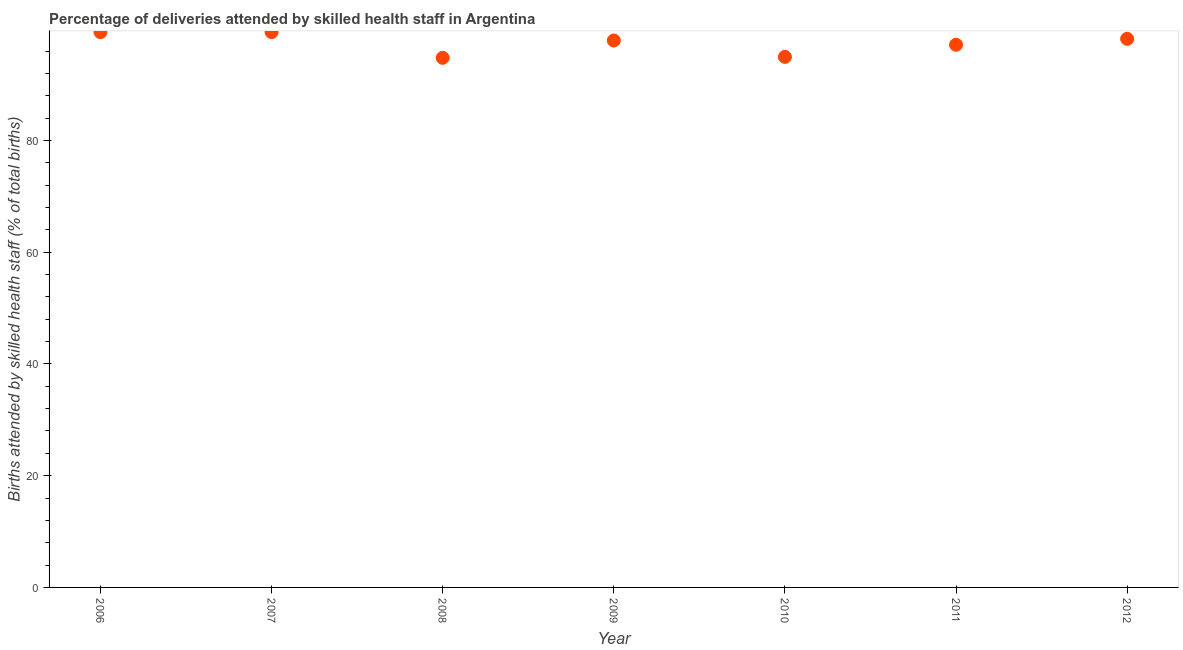What is the number of births attended by skilled health staff in 2007?
Make the answer very short. 99.4. Across all years, what is the maximum number of births attended by skilled health staff?
Your response must be concise. 99.4. Across all years, what is the minimum number of births attended by skilled health staff?
Provide a short and direct response. 94.8. In which year was the number of births attended by skilled health staff minimum?
Ensure brevity in your answer.  2008. What is the sum of the number of births attended by skilled health staff?
Provide a succinct answer. 681.81. What is the difference between the number of births attended by skilled health staff in 2007 and 2010?
Your answer should be compact. 4.43. What is the average number of births attended by skilled health staff per year?
Offer a very short reply. 97.4. What is the median number of births attended by skilled health staff?
Offer a very short reply. 97.9. In how many years, is the number of births attended by skilled health staff greater than 88 %?
Provide a short and direct response. 7. What is the ratio of the number of births attended by skilled health staff in 2008 to that in 2011?
Offer a terse response. 0.98. Is the sum of the number of births attended by skilled health staff in 2011 and 2012 greater than the maximum number of births attended by skilled health staff across all years?
Ensure brevity in your answer.  Yes. What is the difference between the highest and the lowest number of births attended by skilled health staff?
Give a very brief answer. 4.6. What is the difference between two consecutive major ticks on the Y-axis?
Provide a succinct answer. 20. Does the graph contain any zero values?
Your answer should be very brief. No. Does the graph contain grids?
Give a very brief answer. No. What is the title of the graph?
Your answer should be compact. Percentage of deliveries attended by skilled health staff in Argentina. What is the label or title of the X-axis?
Provide a short and direct response. Year. What is the label or title of the Y-axis?
Keep it short and to the point. Births attended by skilled health staff (% of total births). What is the Births attended by skilled health staff (% of total births) in 2006?
Provide a short and direct response. 99.4. What is the Births attended by skilled health staff (% of total births) in 2007?
Provide a succinct answer. 99.4. What is the Births attended by skilled health staff (% of total births) in 2008?
Your response must be concise. 94.8. What is the Births attended by skilled health staff (% of total births) in 2009?
Keep it short and to the point. 97.9. What is the Births attended by skilled health staff (% of total births) in 2010?
Provide a succinct answer. 94.97. What is the Births attended by skilled health staff (% of total births) in 2011?
Ensure brevity in your answer.  97.14. What is the Births attended by skilled health staff (% of total births) in 2012?
Offer a very short reply. 98.2. What is the difference between the Births attended by skilled health staff (% of total births) in 2006 and 2009?
Give a very brief answer. 1.5. What is the difference between the Births attended by skilled health staff (% of total births) in 2006 and 2010?
Ensure brevity in your answer.  4.43. What is the difference between the Births attended by skilled health staff (% of total births) in 2006 and 2011?
Your answer should be very brief. 2.26. What is the difference between the Births attended by skilled health staff (% of total births) in 2006 and 2012?
Ensure brevity in your answer.  1.2. What is the difference between the Births attended by skilled health staff (% of total births) in 2007 and 2009?
Your answer should be compact. 1.5. What is the difference between the Births attended by skilled health staff (% of total births) in 2007 and 2010?
Ensure brevity in your answer.  4.43. What is the difference between the Births attended by skilled health staff (% of total births) in 2007 and 2011?
Provide a short and direct response. 2.26. What is the difference between the Births attended by skilled health staff (% of total births) in 2007 and 2012?
Your response must be concise. 1.2. What is the difference between the Births attended by skilled health staff (% of total births) in 2008 and 2010?
Your response must be concise. -0.17. What is the difference between the Births attended by skilled health staff (% of total births) in 2008 and 2011?
Give a very brief answer. -2.34. What is the difference between the Births attended by skilled health staff (% of total births) in 2009 and 2010?
Provide a short and direct response. 2.93. What is the difference between the Births attended by skilled health staff (% of total births) in 2009 and 2011?
Offer a very short reply. 0.76. What is the difference between the Births attended by skilled health staff (% of total births) in 2010 and 2011?
Give a very brief answer. -2.17. What is the difference between the Births attended by skilled health staff (% of total births) in 2010 and 2012?
Give a very brief answer. -3.23. What is the difference between the Births attended by skilled health staff (% of total births) in 2011 and 2012?
Provide a succinct answer. -1.06. What is the ratio of the Births attended by skilled health staff (% of total births) in 2006 to that in 2007?
Provide a short and direct response. 1. What is the ratio of the Births attended by skilled health staff (% of total births) in 2006 to that in 2008?
Your answer should be compact. 1.05. What is the ratio of the Births attended by skilled health staff (% of total births) in 2006 to that in 2010?
Your response must be concise. 1.05. What is the ratio of the Births attended by skilled health staff (% of total births) in 2006 to that in 2011?
Offer a terse response. 1.02. What is the ratio of the Births attended by skilled health staff (% of total births) in 2007 to that in 2008?
Your answer should be very brief. 1.05. What is the ratio of the Births attended by skilled health staff (% of total births) in 2007 to that in 2009?
Ensure brevity in your answer.  1.01. What is the ratio of the Births attended by skilled health staff (% of total births) in 2007 to that in 2010?
Offer a very short reply. 1.05. What is the ratio of the Births attended by skilled health staff (% of total births) in 2007 to that in 2011?
Make the answer very short. 1.02. What is the ratio of the Births attended by skilled health staff (% of total births) in 2007 to that in 2012?
Make the answer very short. 1.01. What is the ratio of the Births attended by skilled health staff (% of total births) in 2008 to that in 2009?
Provide a short and direct response. 0.97. What is the ratio of the Births attended by skilled health staff (% of total births) in 2008 to that in 2010?
Give a very brief answer. 1. What is the ratio of the Births attended by skilled health staff (% of total births) in 2009 to that in 2010?
Provide a succinct answer. 1.03. What is the ratio of the Births attended by skilled health staff (% of total births) in 2009 to that in 2012?
Your answer should be very brief. 1. What is the ratio of the Births attended by skilled health staff (% of total births) in 2010 to that in 2011?
Your response must be concise. 0.98. What is the ratio of the Births attended by skilled health staff (% of total births) in 2011 to that in 2012?
Your answer should be very brief. 0.99. 